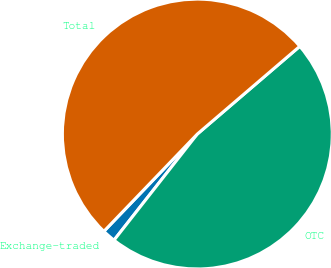Convert chart. <chart><loc_0><loc_0><loc_500><loc_500><pie_chart><fcel>Exchange-traded<fcel>OTC<fcel>Total<nl><fcel>1.59%<fcel>46.86%<fcel>51.55%<nl></chart> 